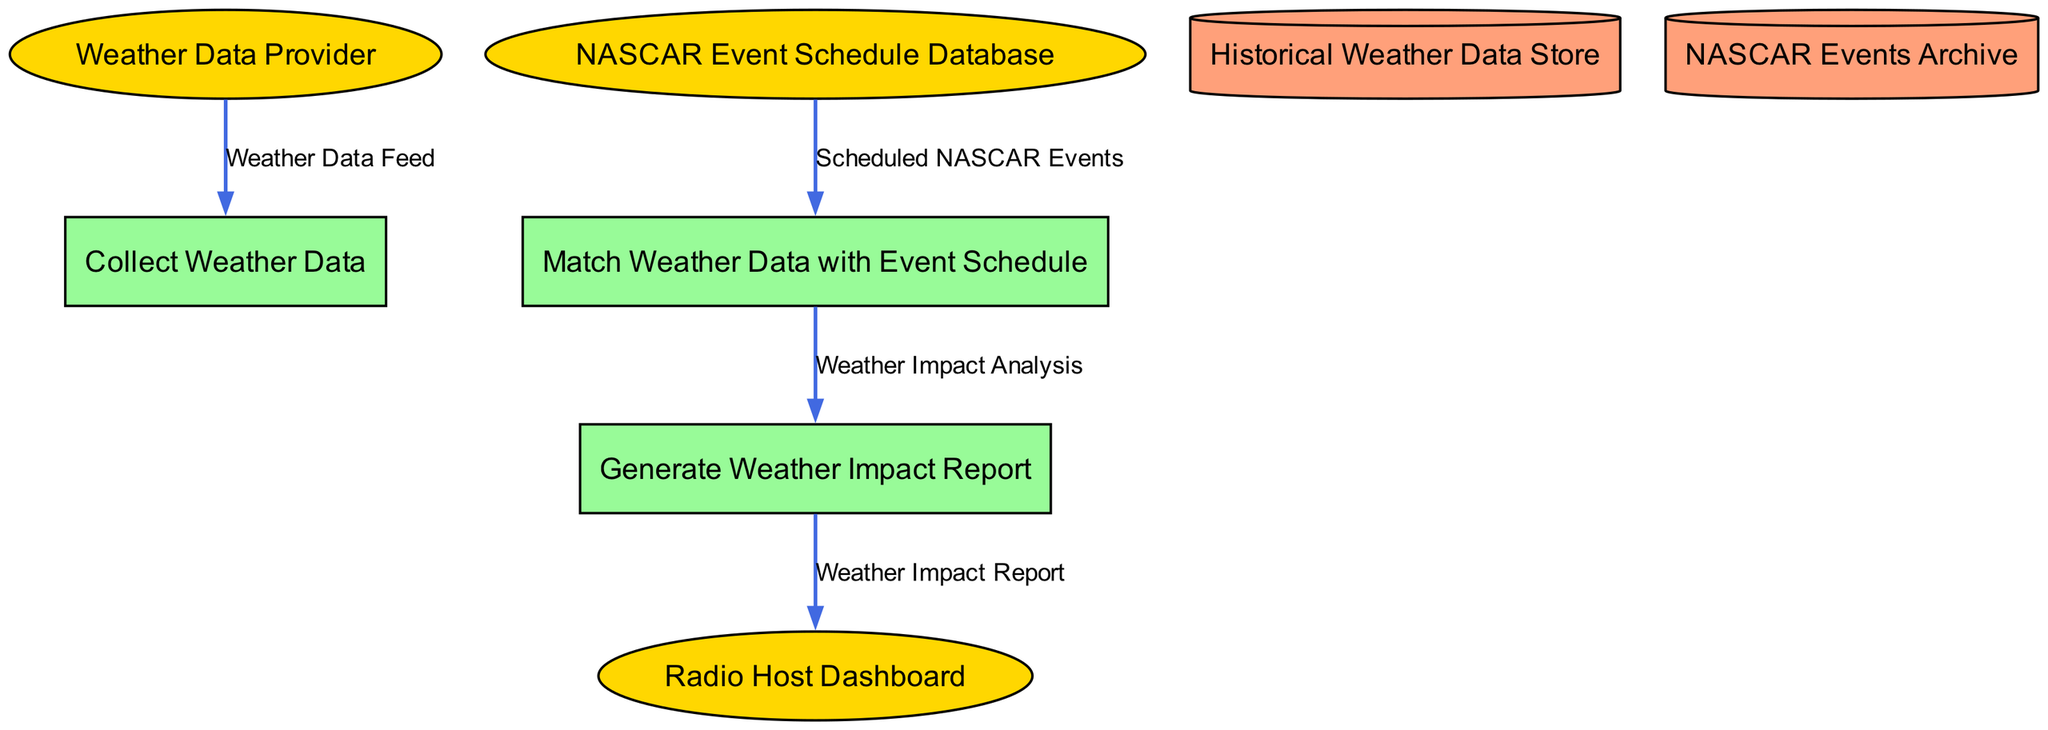What is the name of the external system providing weather data? The diagram shows an external entity named "Weather Data Provider" that supplies weather data.
Answer: Weather Data Provider How many processes are shown in the diagram? The diagram contains three processes: "Collect Weather Data," "Match Weather Data with Event Schedule," and "Generate Weather Impact Report." Therefore, the count of processes is three.
Answer: 3 What is sent from the "Weather Data Provider" to "Collect Weather Data"? The data flow from the "Weather Data Provider" to "Collect Weather Data" is labeled as "Weather Data Feed," indicating that weather data is being sent to this process.
Answer: Weather Data Feed Which data flow results in the generation of the report? The data flow named "Weather Impact Analysis" is the outcome of the process "Match Weather Data with Event Schedule" and flows into the "Generate Weather Impact Report," leading to the creation of the report.
Answer: Weather Impact Analysis What type of storage is used for historical weather data? The diagram indicates a data store called "Historical Weather Data Store," which specifically is used to store historical weather data.
Answer: Historical Weather Data Store What process matches weather data with the NASCAR event schedule? The process titled "Match Weather Data with Event Schedule" is responsible for cross-referencing and matching the weather data with scheduled NASCAR events, as shown in the diagram.
Answer: Match Weather Data with Event Schedule What is the destination of the "Weather Impact Report"? The destination for the "Weather Impact Report" is the "Radio Host Dashboard," as indicated in the data flow labeled "Weather Impact Report."
Answer: Radio Host Dashboard What is stored in the "NASCAR Events Archive"? The "NASCAR Events Archive" is described as a storage system for archiving past NASCAR event schedules and their outcomes, allowing future reference and analysis.
Answer: Past NASCAR event schedules and outcomes 